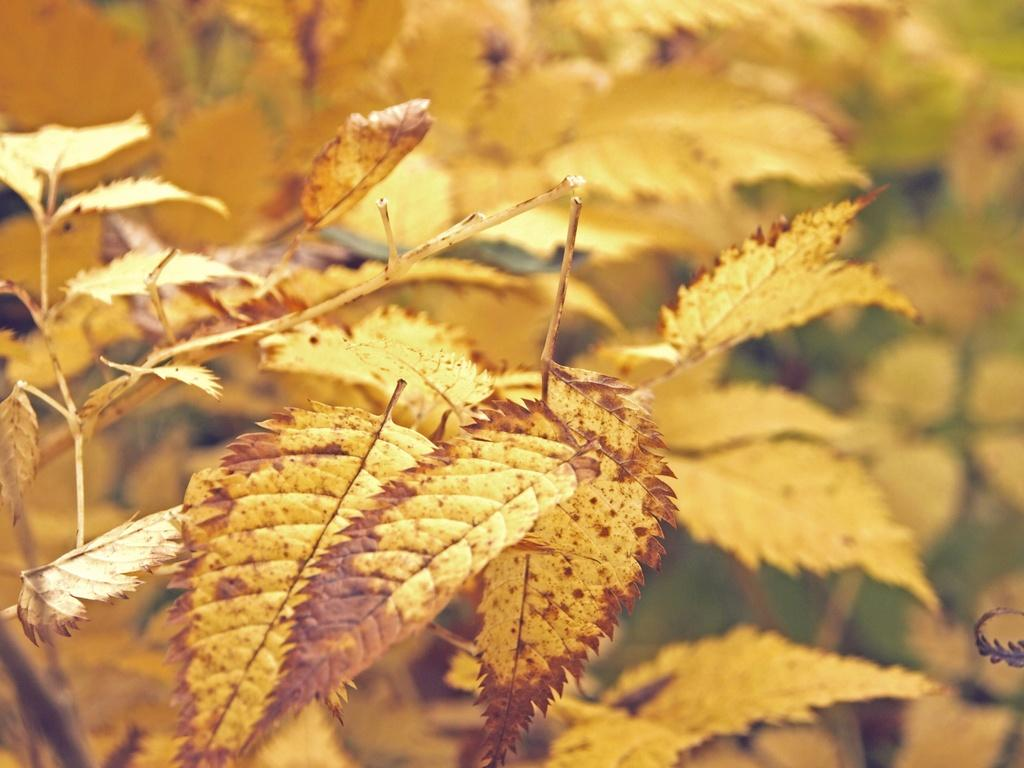What type of plant material can be seen in the image? There are dry leaves in the image. What else related to plants can be seen in the image? The stems of plants are visible in the image. How many bikes are parked near the plants in the image? There is no mention of bikes in the image; it only features dry leaves and plant stems. What type of bee can be seen interacting with the plants in the image? There is no bee present in the image; it only features dry leaves and plant stems. 